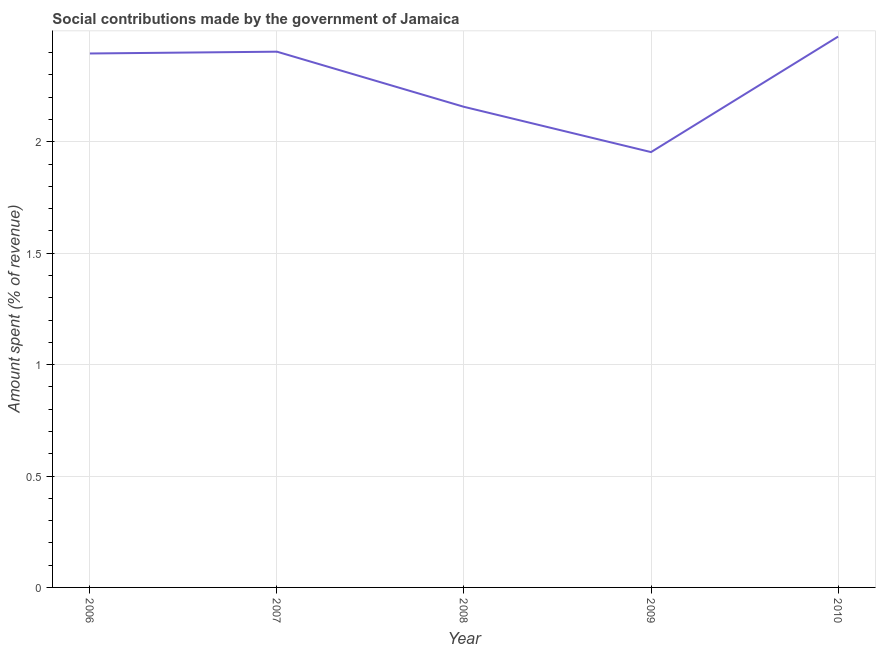What is the amount spent in making social contributions in 2007?
Provide a short and direct response. 2.4. Across all years, what is the maximum amount spent in making social contributions?
Your answer should be very brief. 2.47. Across all years, what is the minimum amount spent in making social contributions?
Offer a very short reply. 1.95. In which year was the amount spent in making social contributions maximum?
Provide a succinct answer. 2010. In which year was the amount spent in making social contributions minimum?
Provide a short and direct response. 2009. What is the sum of the amount spent in making social contributions?
Make the answer very short. 11.38. What is the difference between the amount spent in making social contributions in 2006 and 2007?
Give a very brief answer. -0.01. What is the average amount spent in making social contributions per year?
Provide a short and direct response. 2.28. What is the median amount spent in making social contributions?
Your answer should be compact. 2.4. Do a majority of the years between 2010 and 2006 (inclusive) have amount spent in making social contributions greater than 1.2 %?
Your answer should be compact. Yes. What is the ratio of the amount spent in making social contributions in 2007 to that in 2008?
Keep it short and to the point. 1.11. Is the amount spent in making social contributions in 2008 less than that in 2009?
Offer a very short reply. No. Is the difference between the amount spent in making social contributions in 2006 and 2009 greater than the difference between any two years?
Give a very brief answer. No. What is the difference between the highest and the second highest amount spent in making social contributions?
Offer a very short reply. 0.07. Is the sum of the amount spent in making social contributions in 2006 and 2010 greater than the maximum amount spent in making social contributions across all years?
Provide a succinct answer. Yes. What is the difference between the highest and the lowest amount spent in making social contributions?
Ensure brevity in your answer.  0.52. Does the amount spent in making social contributions monotonically increase over the years?
Offer a terse response. No. How many lines are there?
Your answer should be compact. 1. Does the graph contain grids?
Keep it short and to the point. Yes. What is the title of the graph?
Provide a succinct answer. Social contributions made by the government of Jamaica. What is the label or title of the Y-axis?
Make the answer very short. Amount spent (% of revenue). What is the Amount spent (% of revenue) of 2006?
Give a very brief answer. 2.4. What is the Amount spent (% of revenue) of 2007?
Your answer should be very brief. 2.4. What is the Amount spent (% of revenue) of 2008?
Your answer should be very brief. 2.16. What is the Amount spent (% of revenue) of 2009?
Your answer should be very brief. 1.95. What is the Amount spent (% of revenue) in 2010?
Ensure brevity in your answer.  2.47. What is the difference between the Amount spent (% of revenue) in 2006 and 2007?
Your answer should be compact. -0.01. What is the difference between the Amount spent (% of revenue) in 2006 and 2008?
Make the answer very short. 0.24. What is the difference between the Amount spent (% of revenue) in 2006 and 2009?
Keep it short and to the point. 0.44. What is the difference between the Amount spent (% of revenue) in 2006 and 2010?
Offer a very short reply. -0.08. What is the difference between the Amount spent (% of revenue) in 2007 and 2008?
Provide a succinct answer. 0.25. What is the difference between the Amount spent (% of revenue) in 2007 and 2009?
Your answer should be compact. 0.45. What is the difference between the Amount spent (% of revenue) in 2007 and 2010?
Offer a very short reply. -0.07. What is the difference between the Amount spent (% of revenue) in 2008 and 2009?
Provide a succinct answer. 0.2. What is the difference between the Amount spent (% of revenue) in 2008 and 2010?
Your response must be concise. -0.32. What is the difference between the Amount spent (% of revenue) in 2009 and 2010?
Your answer should be very brief. -0.52. What is the ratio of the Amount spent (% of revenue) in 2006 to that in 2008?
Offer a terse response. 1.11. What is the ratio of the Amount spent (% of revenue) in 2006 to that in 2009?
Offer a very short reply. 1.23. What is the ratio of the Amount spent (% of revenue) in 2006 to that in 2010?
Your answer should be compact. 0.97. What is the ratio of the Amount spent (% of revenue) in 2007 to that in 2008?
Provide a short and direct response. 1.11. What is the ratio of the Amount spent (% of revenue) in 2007 to that in 2009?
Ensure brevity in your answer.  1.23. What is the ratio of the Amount spent (% of revenue) in 2008 to that in 2009?
Provide a short and direct response. 1.1. What is the ratio of the Amount spent (% of revenue) in 2008 to that in 2010?
Offer a very short reply. 0.87. What is the ratio of the Amount spent (% of revenue) in 2009 to that in 2010?
Give a very brief answer. 0.79. 